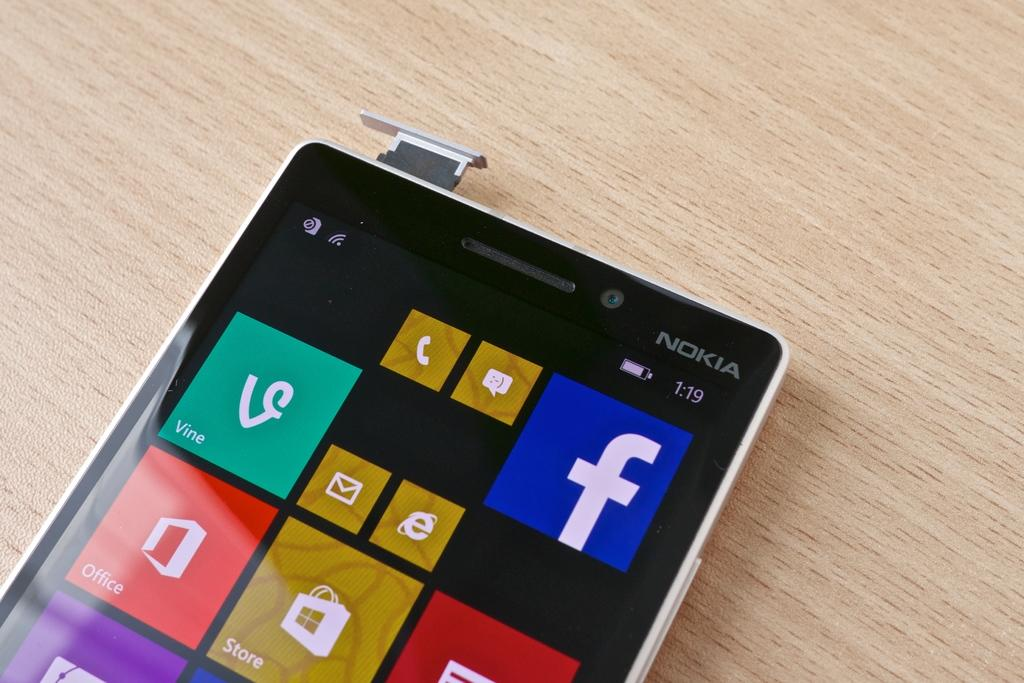Provide a one-sentence caption for the provided image. a Nokia phone with the time of 1:19 on a table. 